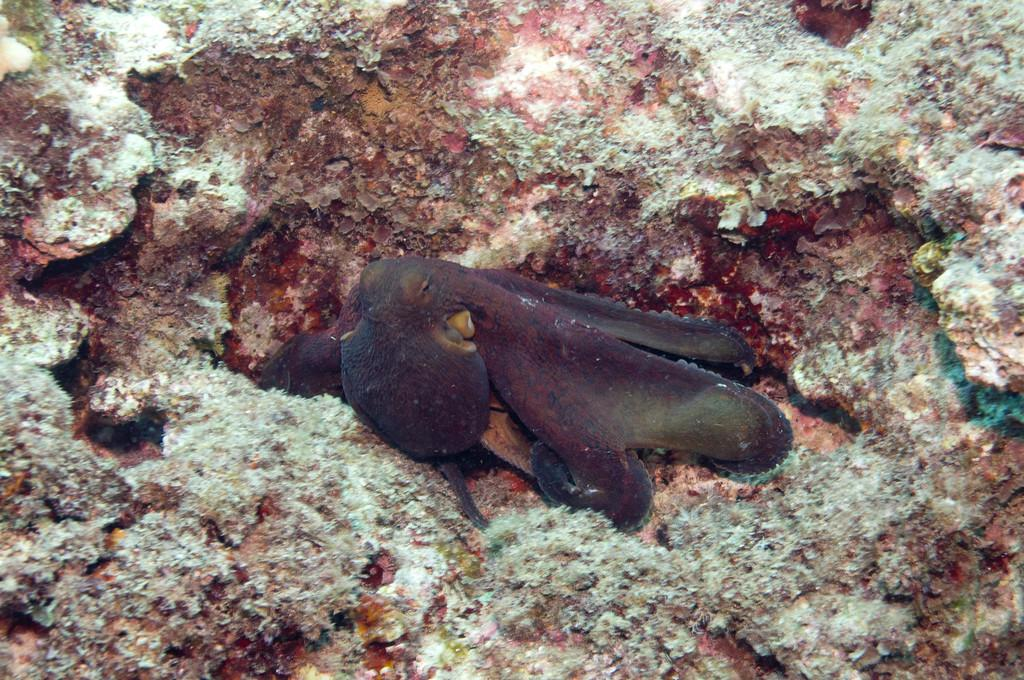What type of animal can be seen in the image? There is an aquatic animal in the image. Where is the aquatic animal located in the image? The aquatic animal is on the ground. What type of soup is the monkey eating in the image? There is no monkey or soup present in the image. 